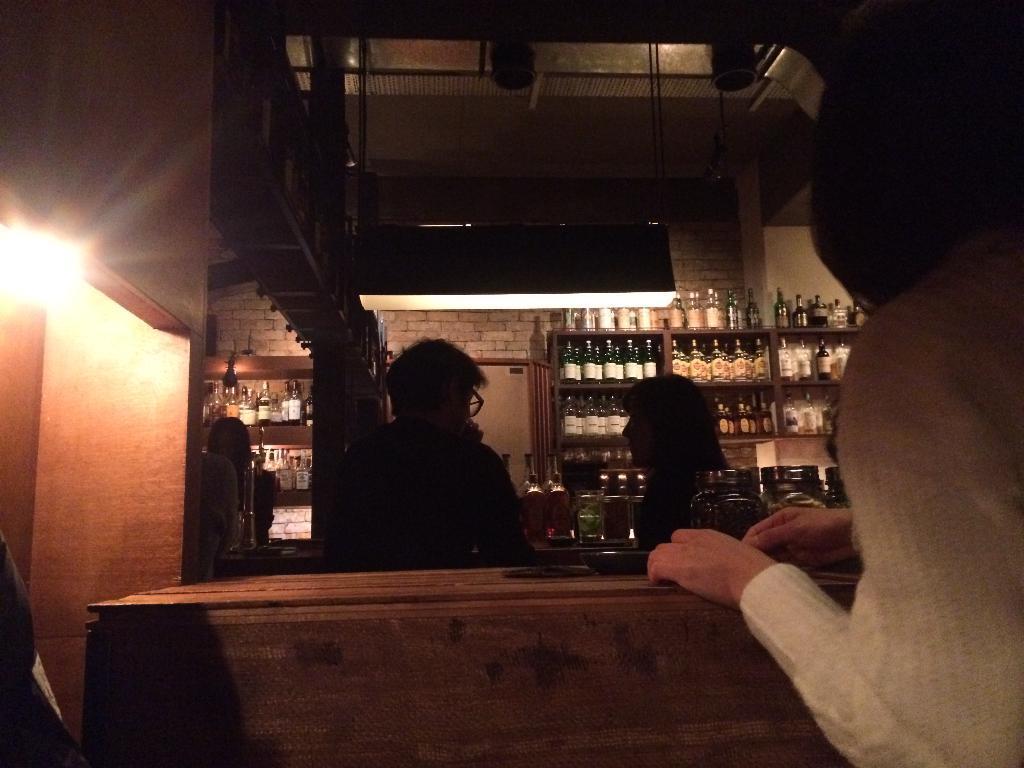Could you give a brief overview of what you see in this image? In this picture I can see few persons, in the background there are bottles on the shelves, on the left side I can see a light. 